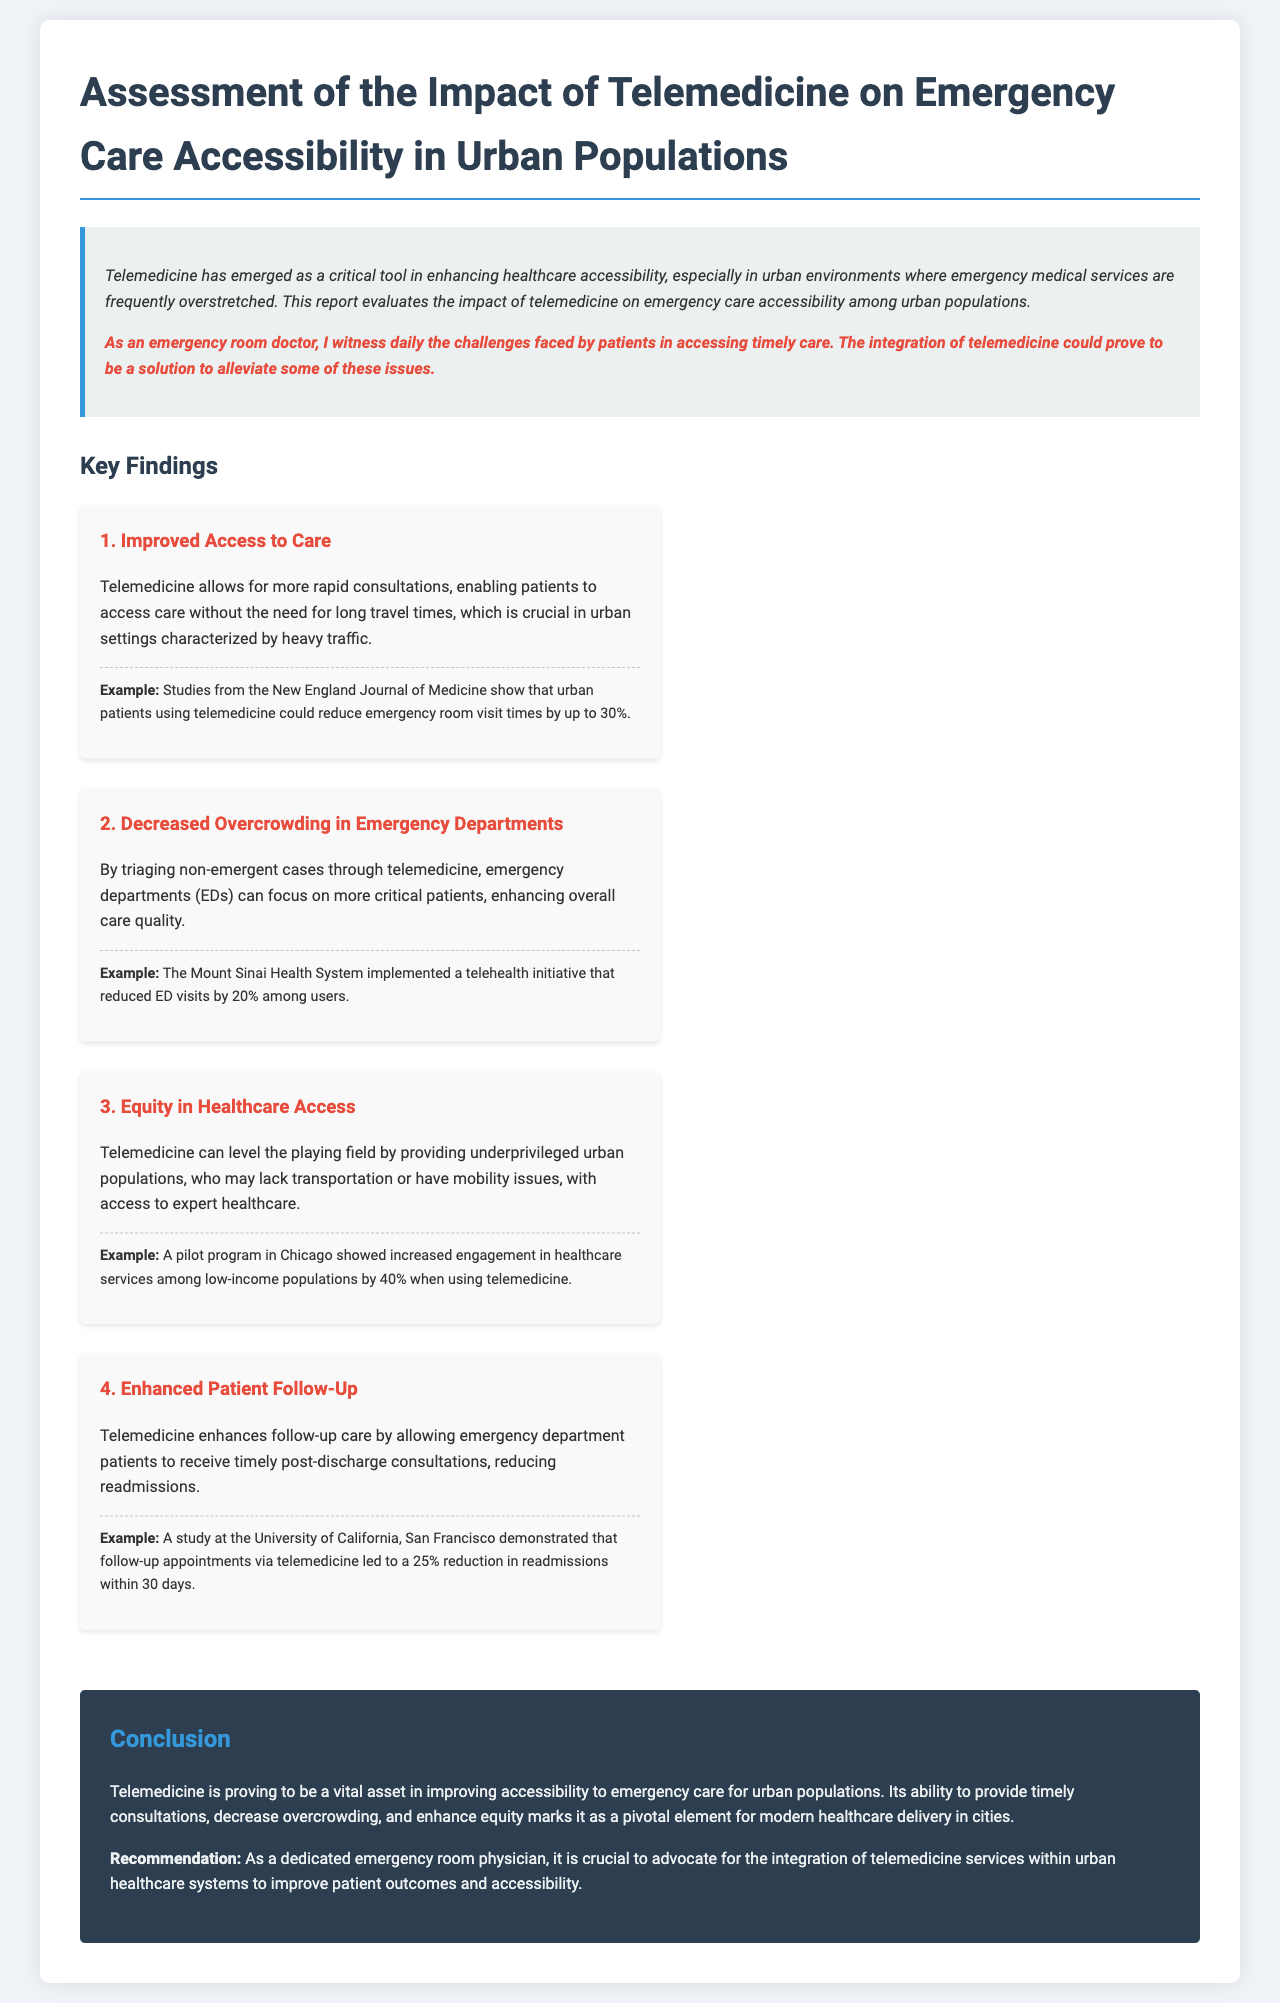What is the title of the report? The title of the report is found at the top of the document, summarizing its focus on telemedicine's impact on emergency care accessibility.
Answer: Assessment of the Impact of Telemedicine on Emergency Care Accessibility in Urban Populations What percentage did telemedicine reduce emergency room visit times by? The report cites findings from the New England Journal of Medicine regarding the reduction in emergency room visit times due to telemedicine.
Answer: Up to 30% What was the reduction in ED visits among users of the Mount Sinai Health System telehealth initiative? The report provides an example of the Mount Sinai Health System's telehealth initiative that demonstrated a specific percentage reduction in ED visits.
Answer: 20% What type of populations did telemedicine improve access for according to the report? The report discusses the benefits of telemedicine for specific demographics that face barriers to accessing healthcare services.
Answer: Underprivileged urban populations What was the reduction in readmissions within 30 days due to follow-up appointments via telemedicine? A specific study mentioned in the document highlights the impact of telemedicine on readmission rates for emergency department patients.
Answer: 25% Why should emergency room physicians advocate for telemedicine integration? The document outlines recommendations emphasizing the role of telemedicine in improving patient outcomes and accessibility.
Answer: To improve patient outcomes and accessibility 